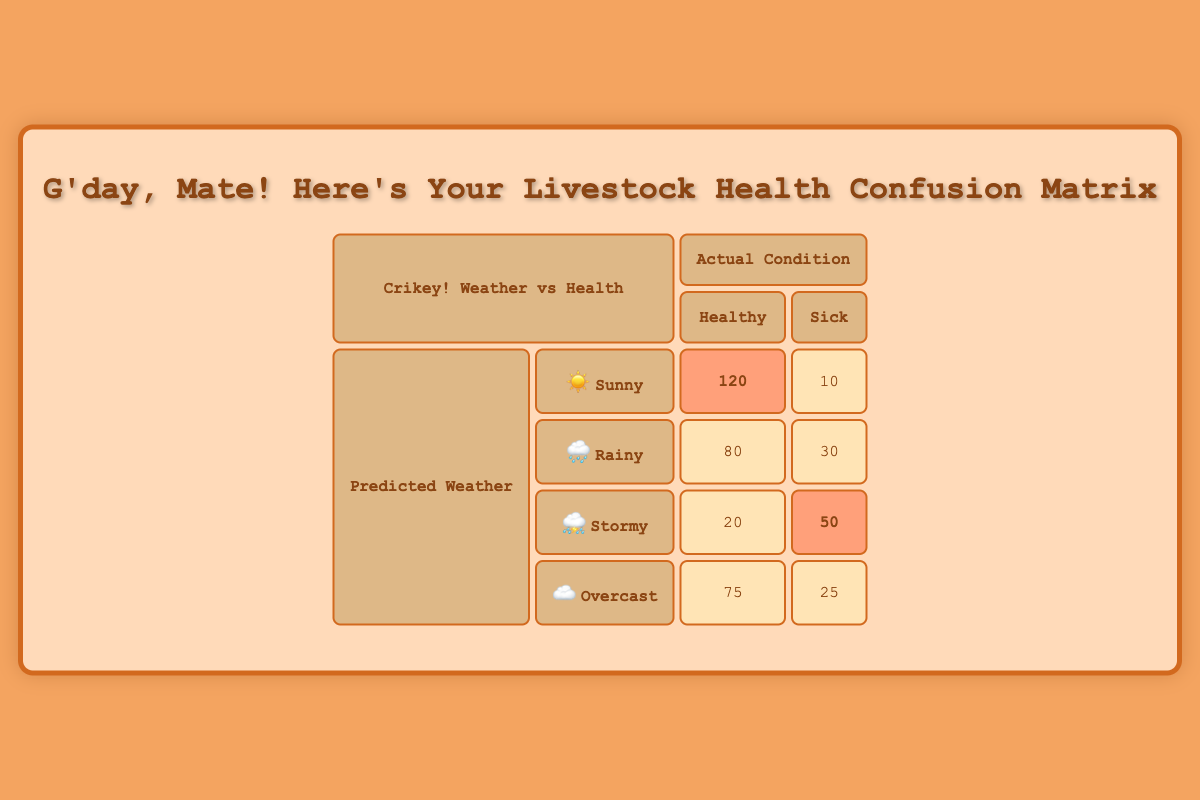What is the predicted condition when the actual condition is sick? The rows for "Sick" show the predicted conditions as follows: Sunny (10), Rainy (30), Stormy (50), and Overcast (25). Therefore, if sick, it can be Sunny, Rainy, Stormy, or Overcast
Answer: Sunny, Rainy, Stormy, Overcast How many healthy livestock were predicted to be under rainy conditions? In the row corresponding to Rainy under "Healthy," the count is 80. This value represents the number of healthy livestock predicted during rainy weather conditions
Answer: 80 What is the total number of sick livestock predicted in stormy conditions? Referring to the Stormy row, the count for Sick is 50. Thus, the total number of sick livestock predicted in stormy weather is the direct value from that row
Answer: 50 What is the average number of healthy livestock across all predicted weather conditions? To find the average number of healthy livestock, we need to sum the counts: 120 (Sunny) + 80 (Rainy) + 20 (Stormy) + 75 (Overcast) = 295. There are 4 weather conditions, so the average is 295/4 = 73.75
Answer: 73.75 Is there a weather condition that predicted fewer healthy livestock than sick livestock? By examining the table, the "Stormy" condition has 20 healthy and 50 sick. Hence, it is true that stormy weather predicted fewer healthy than sick livestock
Answer: Yes Which weather condition predicted the highest count of healthy livestock? Analyzing the "Healthy" counts: Sunny (120), Rainy (80), Stormy (20), and Overcast (75). Sunny has the highest value of 120
Answer: Sunny What is the combined total of healthy livestock predicted for sunny and overcast conditions? The healthy livestock for Sunny is 120 and for Overcast is 75. Adding these two values gives 120 + 75 = 195 healthy livestock predicted under sunny and overcast conditions
Answer: 195 Are there more sick livestock predicted under rainy conditions than under overcast conditions? For Rainy, the sick count is 30, while for Overcast, it is 25. Since 30 is greater than 25, the statement is true
Answer: Yes 